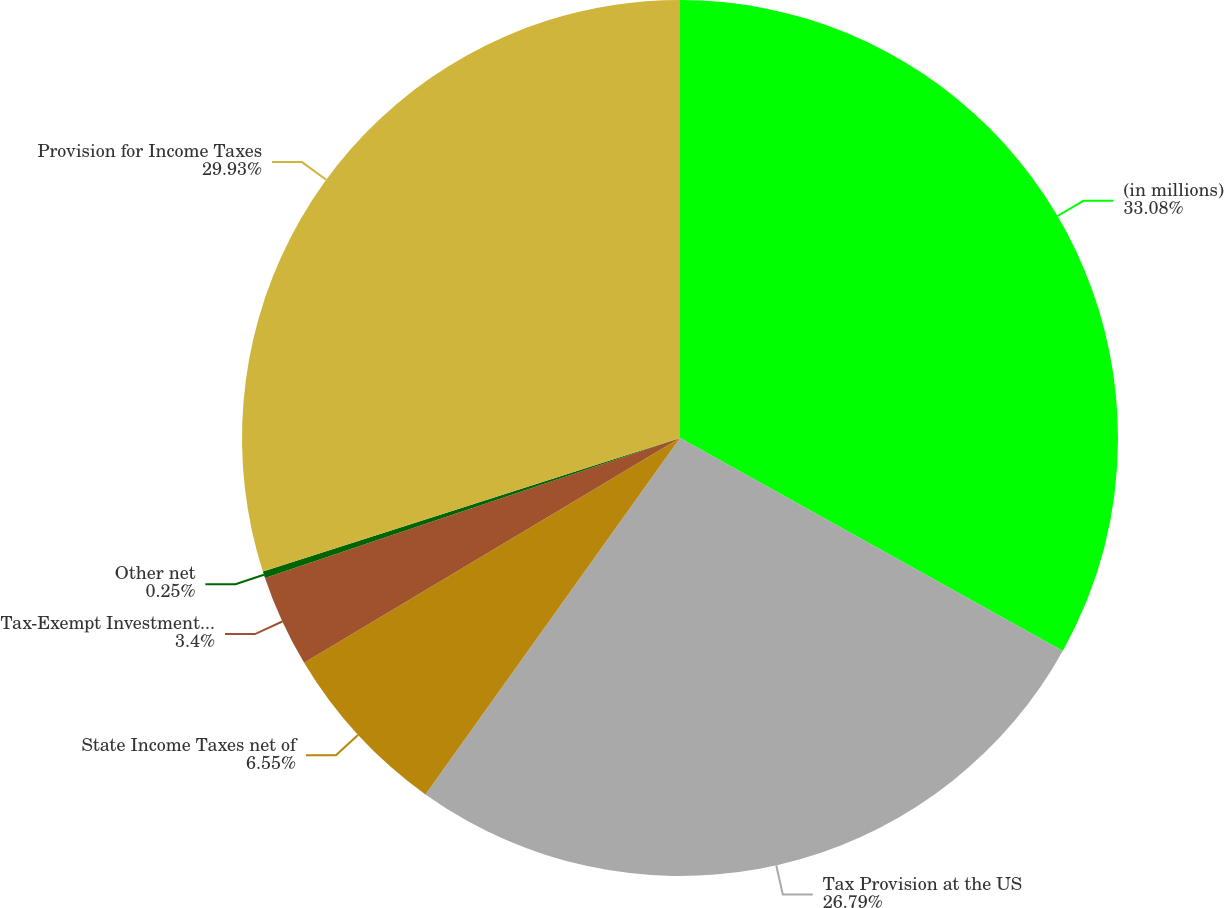<chart> <loc_0><loc_0><loc_500><loc_500><pie_chart><fcel>(in millions)<fcel>Tax Provision at the US<fcel>State Income Taxes net of<fcel>Tax-Exempt Investment Income<fcel>Other net<fcel>Provision for Income Taxes<nl><fcel>33.08%<fcel>26.79%<fcel>6.55%<fcel>3.4%<fcel>0.25%<fcel>29.93%<nl></chart> 